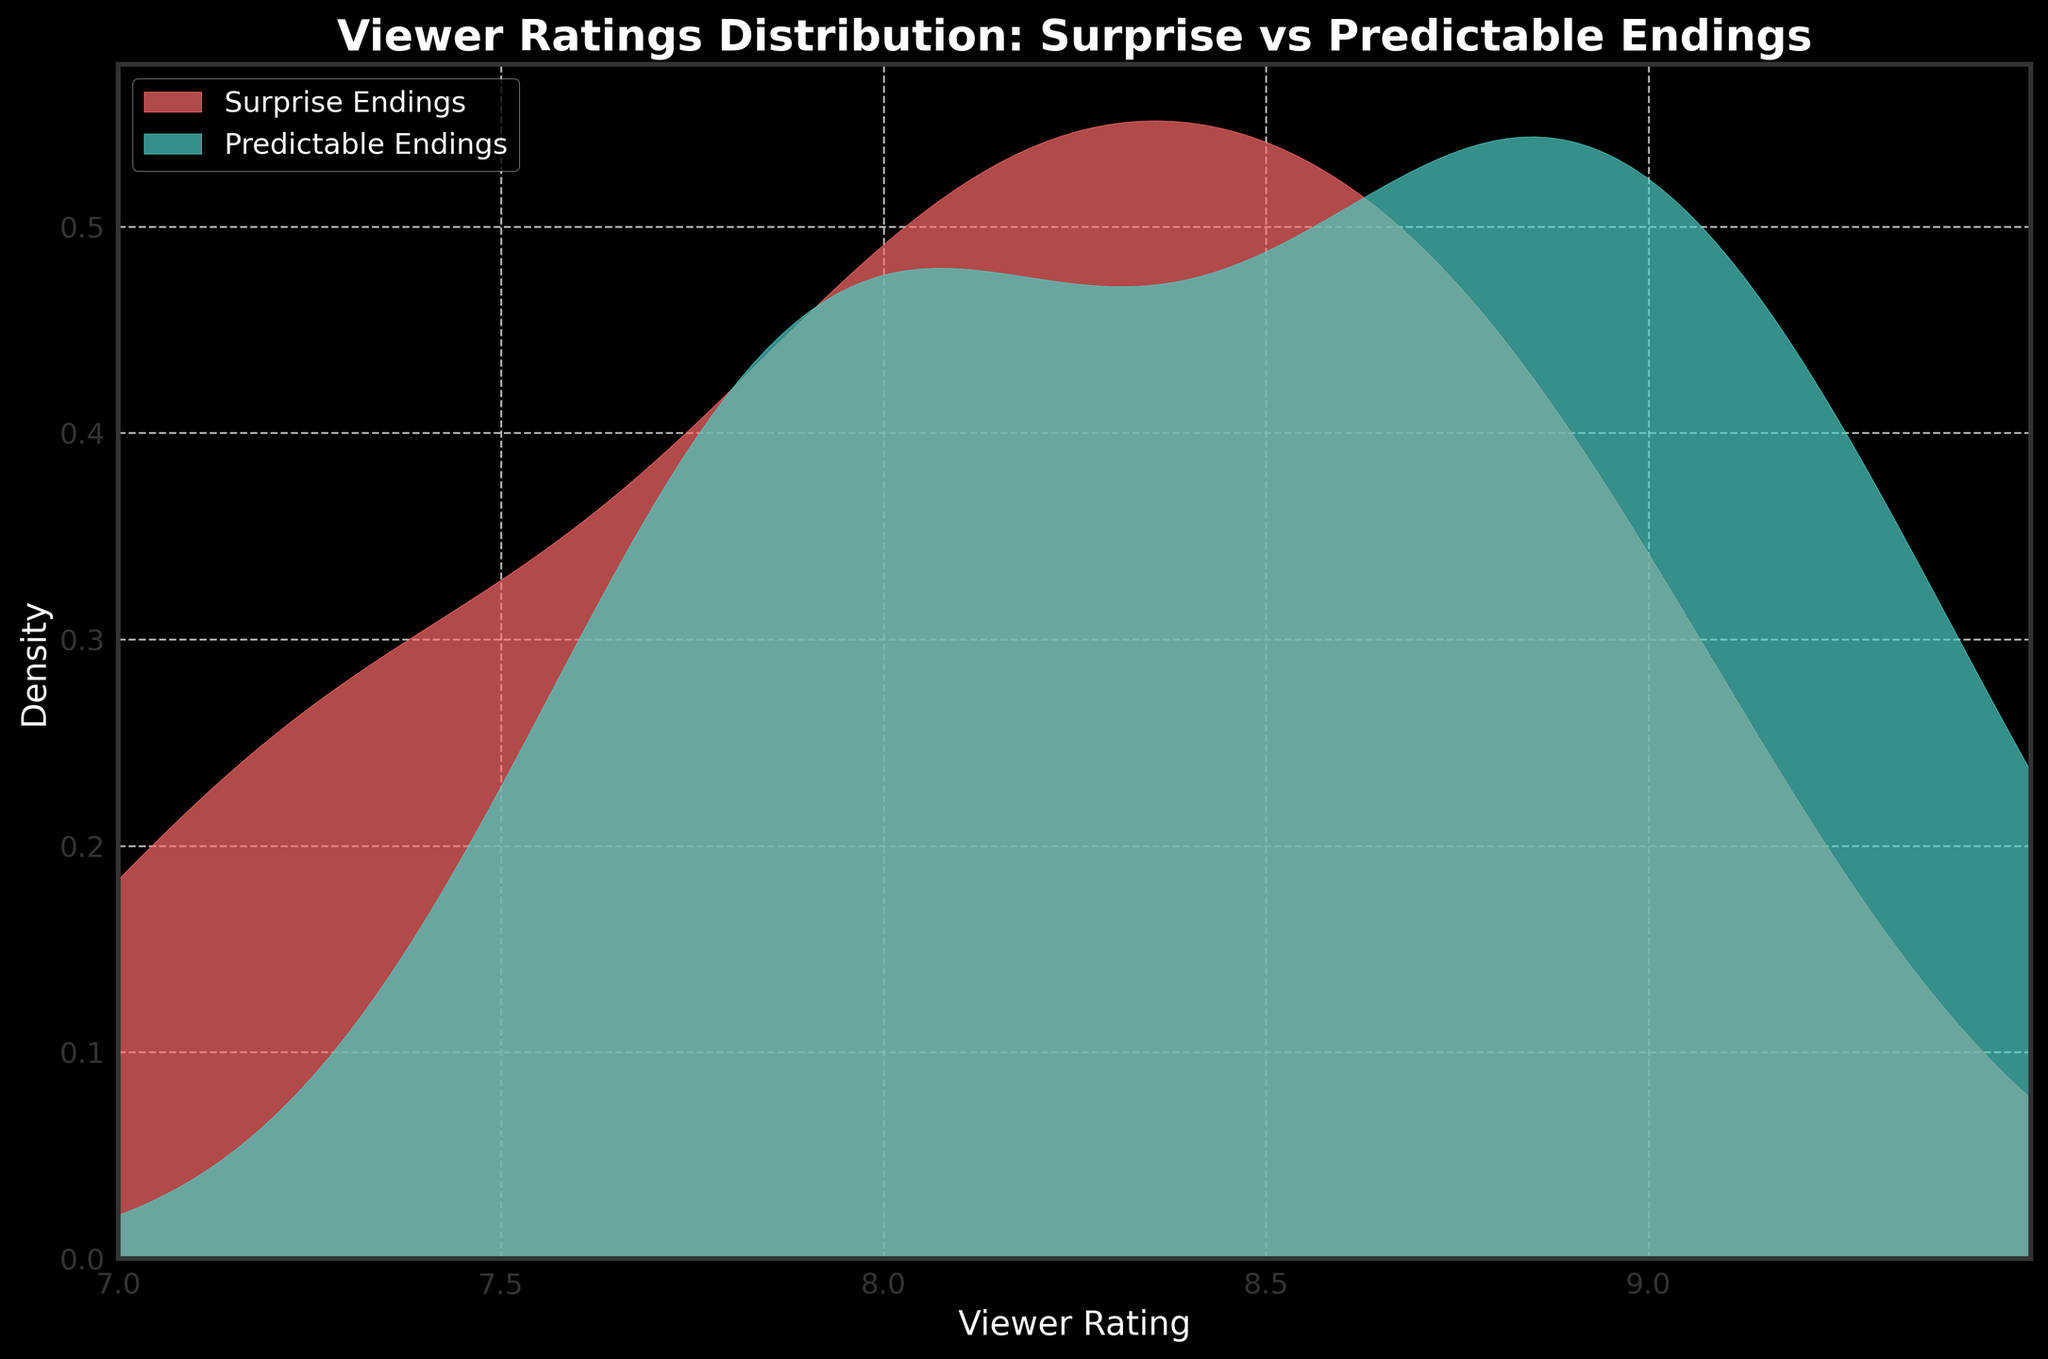what are the axis labels? The x-axis is labeled "Viewer Rating" and the y-axis is labeled "Density."
Answer: Viewer Rating, Density what does the legend indicate? The legend indicates that the red shaded area represents "Surprise Endings," and the turquoise shaded area represents "Predictable Endings."
Answer: Surprise Endings, Predictable Endings what's the highest rating on the x-axis? The x-axis ranges from 7 to 9.5, with the highest rating being 9.5.
Answer: 9.5 which type of ending has a higher density at viewer ratings around 8.0? The density plot for Predictable Endings has a higher peak around the 8.0 mark compared to Surprise Endings, indicating a higher density.
Answer: Predictable Endings how do the peaks of the two distributions compare? The peak density for Predictable Endings is higher and sharper compared to Surprise Endings, which has a lower and more spread out peak.
Answer: Predictable Endings has a higher peak what's the range of viewer ratings where both distributions overlap significantly? Both distributions significantly overlap in the viewer rating range from 7.8 to around 8.6.
Answer: 7.8 to 8.6 which type of ending has a wider spread in viewer ratings? The Surprise Endings distribution is wider, indicating a broader range of viewer ratings compared to Predictable Endings.
Answer: Surprise Endings is there a rating where both distributions have the same density? Both distributions appear to have a similar density around the 8.1 mark.
Answer: Around 8.1 how does the density of viewer ratings above 9.0 compare between the two endings? Viewer ratings above 9.0 have higher density for Predictable Endings, whereas Surprise Endings have minimal density in this range.
Answer: Predictable Endings have higher density above 9.0 